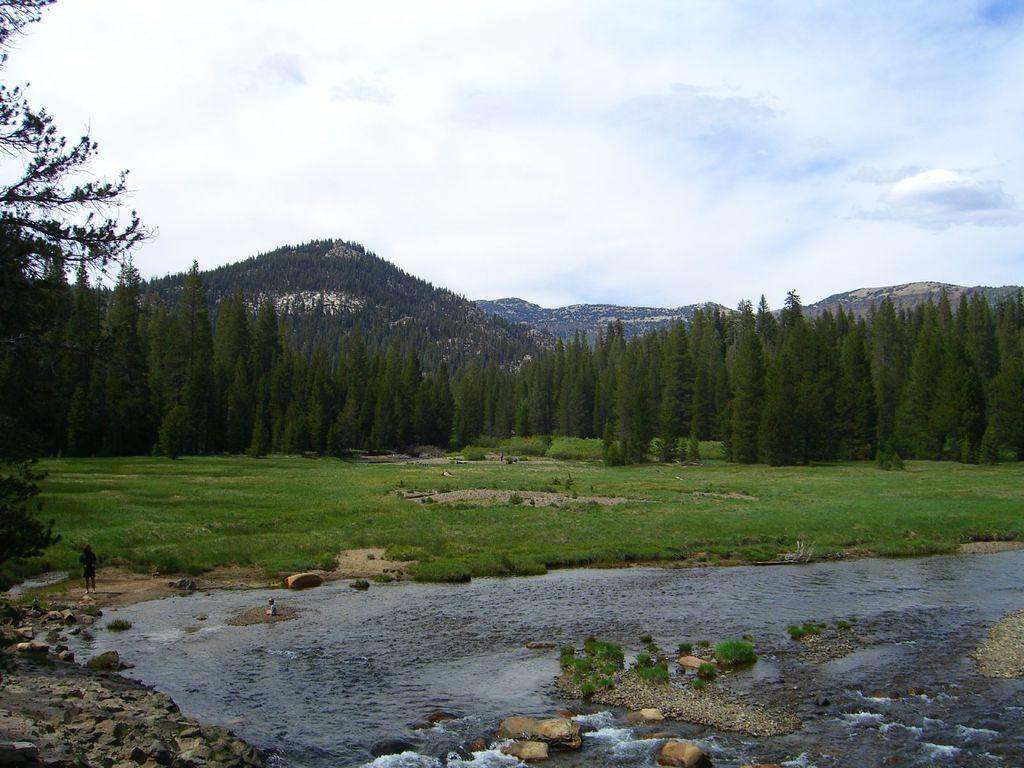What is happening at the bottom of the image? Water is flowing at the bottom of the image. What can be seen in the middle of the image? There are trees in the middle of the image. What type of landscape feature is visible at the back side of the image? There are hills visible at the back side of the image. What is visible at the top of the image? The sky is visible at the top of the image. Can you tell me how many facts are mentioned in the image? There is no mention of facts in the image; it features water flowing, trees, hills, and the sky. Is there a wall visible in the image? No, there is no wall present in the image. 